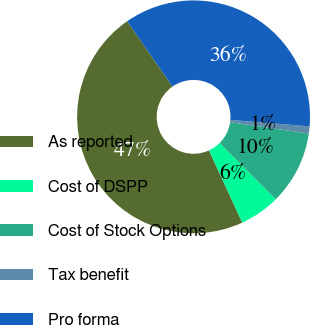Convert chart to OTSL. <chart><loc_0><loc_0><loc_500><loc_500><pie_chart><fcel>As reported<fcel>Cost of DSPP<fcel>Cost of Stock Options<fcel>Tax benefit<fcel>Pro forma<nl><fcel>47.2%<fcel>5.61%<fcel>10.23%<fcel>0.99%<fcel>35.98%<nl></chart> 